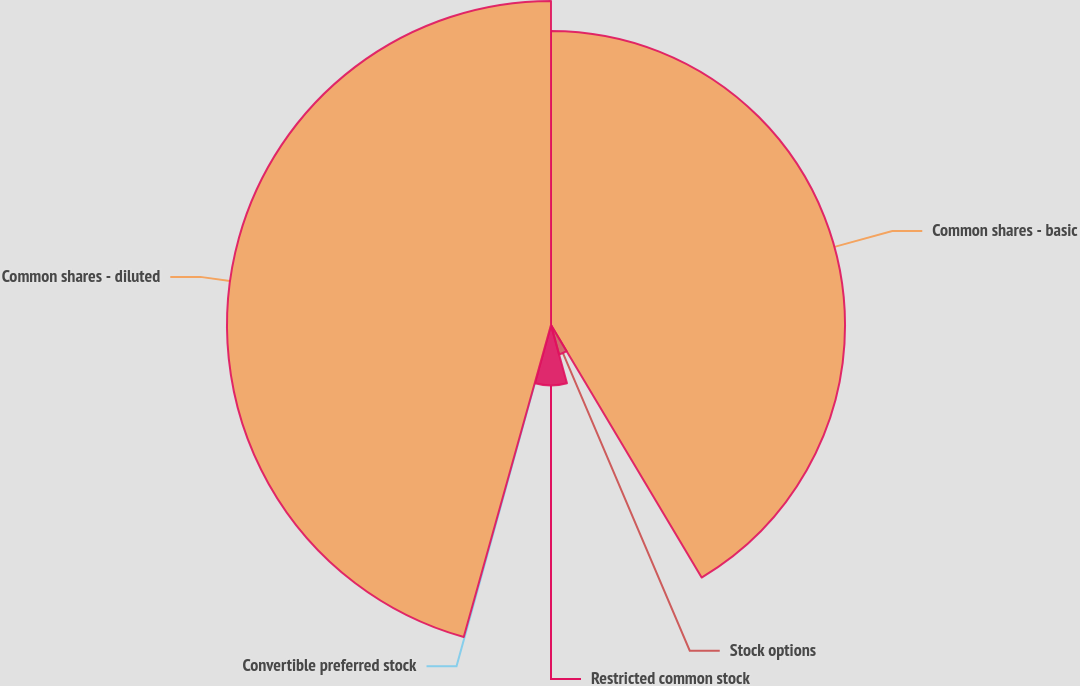Convert chart. <chart><loc_0><loc_0><loc_500><loc_500><pie_chart><fcel>Common shares - basic<fcel>Stock options<fcel>Restricted common stock<fcel>Convertible preferred stock<fcel>Common shares - diluted<nl><fcel>41.44%<fcel>4.3%<fcel>8.52%<fcel>0.08%<fcel>45.66%<nl></chart> 